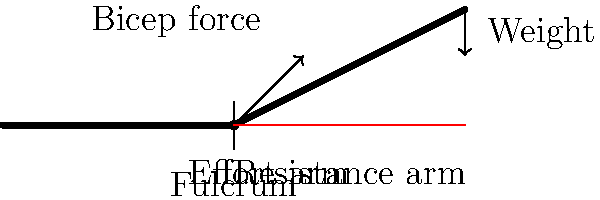In the context of a bicep curl exercise, which class of lever system is demonstrated by the human arm, and how does this affect the mechanical advantage of the movement? To answer this question, let's analyze the diagram and the mechanics of a bicep curl:

1. Identify the components of the lever system:
   - Fulcrum: The elbow joint
   - Effort: The bicep muscle force
   - Resistance: The weight being lifted

2. Determine the arrangement of these components:
   - The fulcrum (elbow) is between the effort (bicep force) and the resistance (weight).
   - This arrangement corresponds to a Class III lever system.

3. Understand the characteristics of a Class III lever:
   - The effort is always between the fulcrum and the resistance.
   - The effort arm is always shorter than the resistance arm.

4. Calculate the mechanical advantage:
   - Mechanical Advantage (MA) = Resistance Arm / Effort Arm
   - In this case, the resistance arm is longer than the effort arm.
   - Therefore, MA < 1, which means there is a mechanical disadvantage.

5. Interpret the implications:
   - A mechanical disadvantage means more force is required to lift the weight.
   - However, it allows for greater speed and range of motion in the movement.

6. Relate to historical context:
   - This principle has been understood since ancient times, with Archimedes (287-212 BCE) being one of the first to document the laws of levers.
   - The understanding of biomechanics has greatly influenced the development of tools and machines throughout history.
Answer: Class III lever system with mechanical disadvantage (MA < 1) 